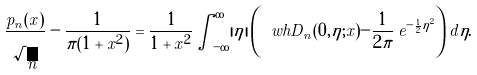Convert formula to latex. <formula><loc_0><loc_0><loc_500><loc_500>\frac { p _ { n } ( x ) } { \sqrt { n } } - \frac { 1 } { \pi ( 1 + x ^ { 2 } ) } = \frac { 1 } { 1 + x ^ { 2 } } \int _ { - \infty } ^ { \infty } | \eta | \left ( \ w h D _ { n } ( 0 , \eta ; x ) - \frac { 1 } { 2 \pi } \, e ^ { - \frac { 1 } { 2 } \eta ^ { 2 } } \right ) d \eta .</formula> 